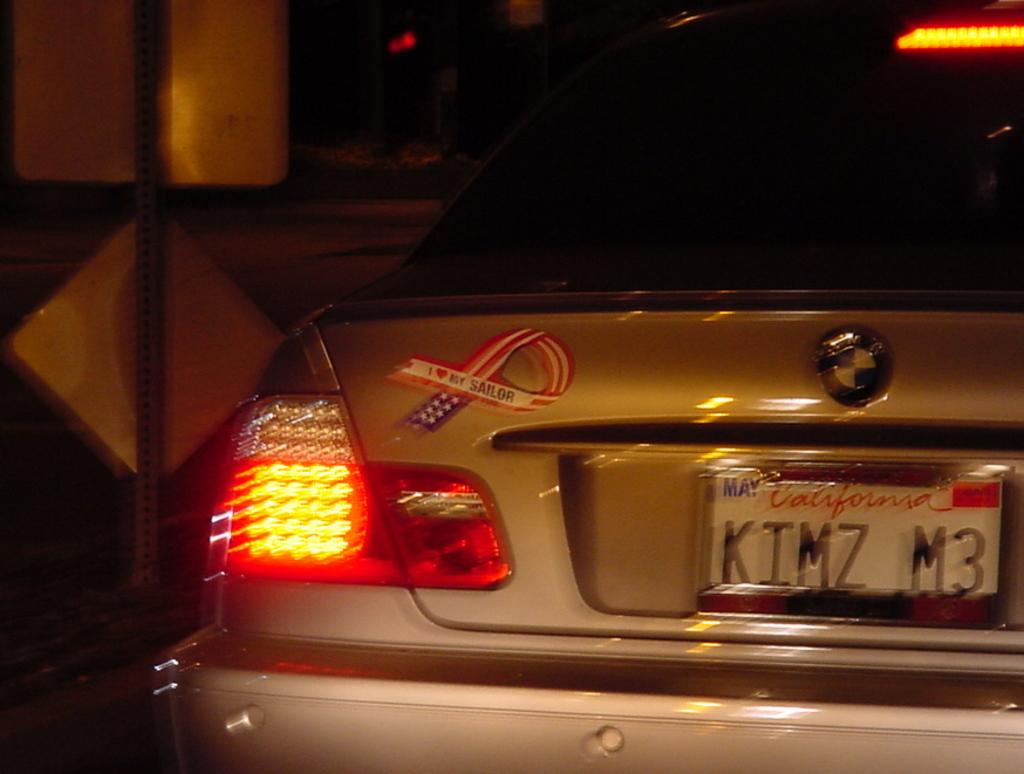What is the license plate number?
Ensure brevity in your answer.  Kimz m3. 